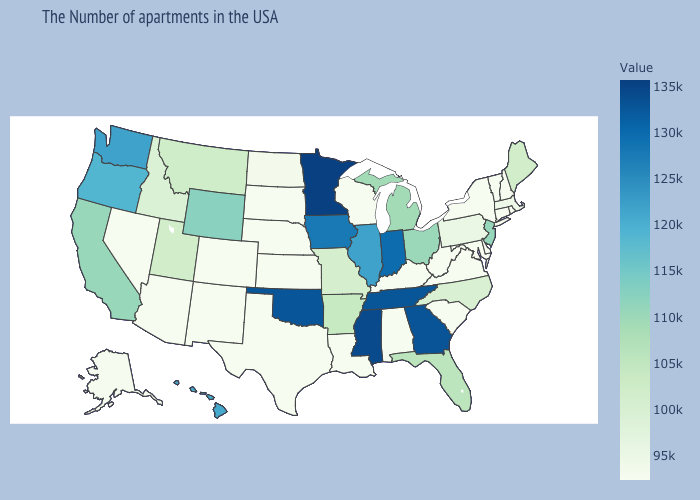Does Massachusetts have the lowest value in the Northeast?
Answer briefly. No. Does Washington have the highest value in the West?
Keep it brief. Yes. Which states have the lowest value in the USA?
Short answer required. Rhode Island, New Hampshire, Vermont, Connecticut, New York, Delaware, Maryland, Virginia, South Carolina, West Virginia, Kentucky, Alabama, Wisconsin, Louisiana, Kansas, Nebraska, Texas, South Dakota, Colorado, New Mexico, Arizona, Nevada. Does New Jersey have a lower value than Hawaii?
Short answer required. Yes. Does Connecticut have the highest value in the USA?
Answer briefly. No. Does Illinois have the highest value in the MidWest?
Quick response, please. No. Does Arizona have the lowest value in the USA?
Quick response, please. Yes. Does Minnesota have the highest value in the USA?
Be succinct. Yes. Does the map have missing data?
Short answer required. No. 